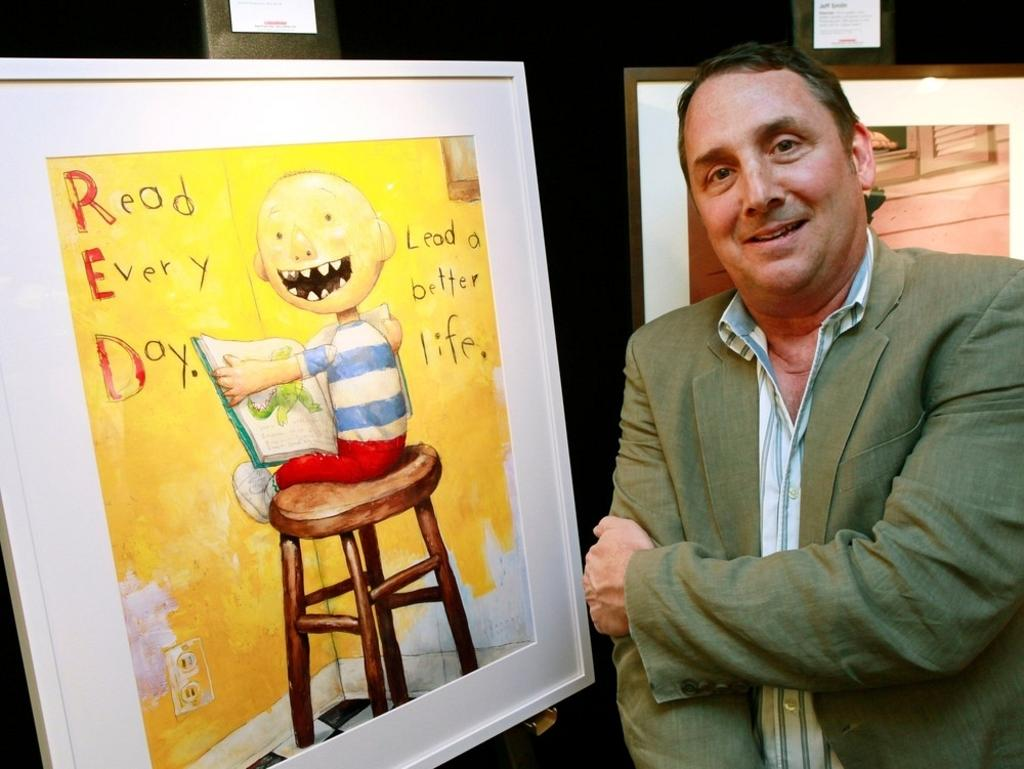What is the man in the image doing? The man is standing in the image. What is the man wearing in the image? The man is wearing a coat in the image. What is the man's facial expression in the image? The man is smiling in the image. What is the man standing beside in the image? The man is standing beside a board in the image. What is attached to the board in the image? A chart is stuck to the board in the image. What is depicted on the chart in the image? The chart contains a painting of a boy in the image. What is the boy doing in the painting on the chart? The boy is sitting on a stool in the painting on the chart. How many pies are being served on the boat in the image? There is no boat or pies present in the image. What act is the man performing in the image? The man is simply standing in the image, not performing any act. 